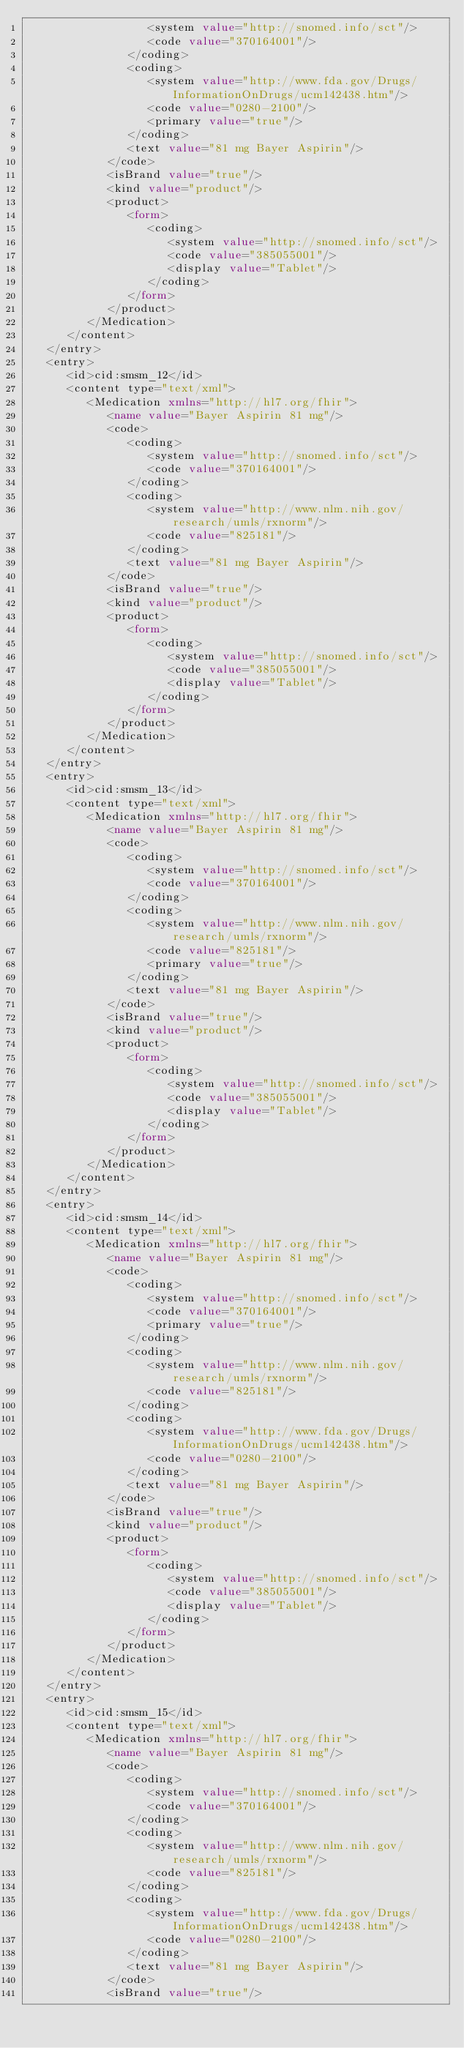<code> <loc_0><loc_0><loc_500><loc_500><_XML_>                  <system value="http://snomed.info/sct"/>
                  <code value="370164001"/>
               </coding>
               <coding>
                  <system value="http://www.fda.gov/Drugs/InformationOnDrugs/ucm142438.htm"/>
                  <code value="0280-2100"/>
                  <primary value="true"/>
               </coding>
               <text value="81 mg Bayer Aspirin"/>
            </code>
            <isBrand value="true"/>
            <kind value="product"/>
            <product>
               <form>
                  <coding>
                     <system value="http://snomed.info/sct"/>
                     <code value="385055001"/>
                     <display value="Tablet"/>
                  </coding>
               </form>
            </product>
         </Medication>
      </content>
   </entry>
   <entry>
      <id>cid:smsm_12</id>
      <content type="text/xml">
         <Medication xmlns="http://hl7.org/fhir">
            <name value="Bayer Aspirin 81 mg"/>
            <code>
               <coding>
                  <system value="http://snomed.info/sct"/>
                  <code value="370164001"/>
               </coding>
               <coding>
                  <system value="http://www.nlm.nih.gov/research/umls/rxnorm"/>
                  <code value="825181"/>
               </coding>
               <text value="81 mg Bayer Aspirin"/>
            </code>
            <isBrand value="true"/>
            <kind value="product"/>
            <product>
               <form>
                  <coding>
                     <system value="http://snomed.info/sct"/>
                     <code value="385055001"/>
                     <display value="Tablet"/>
                  </coding>
               </form>
            </product>
         </Medication>
      </content>
   </entry>
   <entry>
      <id>cid:smsm_13</id>
      <content type="text/xml">
         <Medication xmlns="http://hl7.org/fhir">
            <name value="Bayer Aspirin 81 mg"/>
            <code>
               <coding>
                  <system value="http://snomed.info/sct"/>
                  <code value="370164001"/>
               </coding>
               <coding>
                  <system value="http://www.nlm.nih.gov/research/umls/rxnorm"/>
                  <code value="825181"/>
                  <primary value="true"/>
               </coding>
               <text value="81 mg Bayer Aspirin"/>
            </code>
            <isBrand value="true"/>
            <kind value="product"/>
            <product>
               <form>
                  <coding>
                     <system value="http://snomed.info/sct"/>
                     <code value="385055001"/>
                     <display value="Tablet"/>
                  </coding>
               </form>
            </product>
         </Medication>
      </content>
   </entry>
   <entry>
      <id>cid:smsm_14</id>
      <content type="text/xml">
         <Medication xmlns="http://hl7.org/fhir">
            <name value="Bayer Aspirin 81 mg"/>
            <code>
               <coding>
                  <system value="http://snomed.info/sct"/>
                  <code value="370164001"/>
                  <primary value="true"/>
               </coding>
               <coding>
                  <system value="http://www.nlm.nih.gov/research/umls/rxnorm"/>
                  <code value="825181"/>
               </coding>
               <coding>
                  <system value="http://www.fda.gov/Drugs/InformationOnDrugs/ucm142438.htm"/>
                  <code value="0280-2100"/>
               </coding>
               <text value="81 mg Bayer Aspirin"/>
            </code>
            <isBrand value="true"/>
            <kind value="product"/>
            <product>
               <form>
                  <coding>
                     <system value="http://snomed.info/sct"/>
                     <code value="385055001"/>
                     <display value="Tablet"/>
                  </coding>
               </form>
            </product>
         </Medication>
      </content>
   </entry>
   <entry>
      <id>cid:smsm_15</id>
      <content type="text/xml">
         <Medication xmlns="http://hl7.org/fhir">
            <name value="Bayer Aspirin 81 mg"/>
            <code>
               <coding>
                  <system value="http://snomed.info/sct"/>
                  <code value="370164001"/>
               </coding>
               <coding>
                  <system value="http://www.nlm.nih.gov/research/umls/rxnorm"/>
                  <code value="825181"/>
               </coding>
               <coding>
                  <system value="http://www.fda.gov/Drugs/InformationOnDrugs/ucm142438.htm"/>
                  <code value="0280-2100"/>
               </coding>
               <text value="81 mg Bayer Aspirin"/>
            </code>
            <isBrand value="true"/></code> 